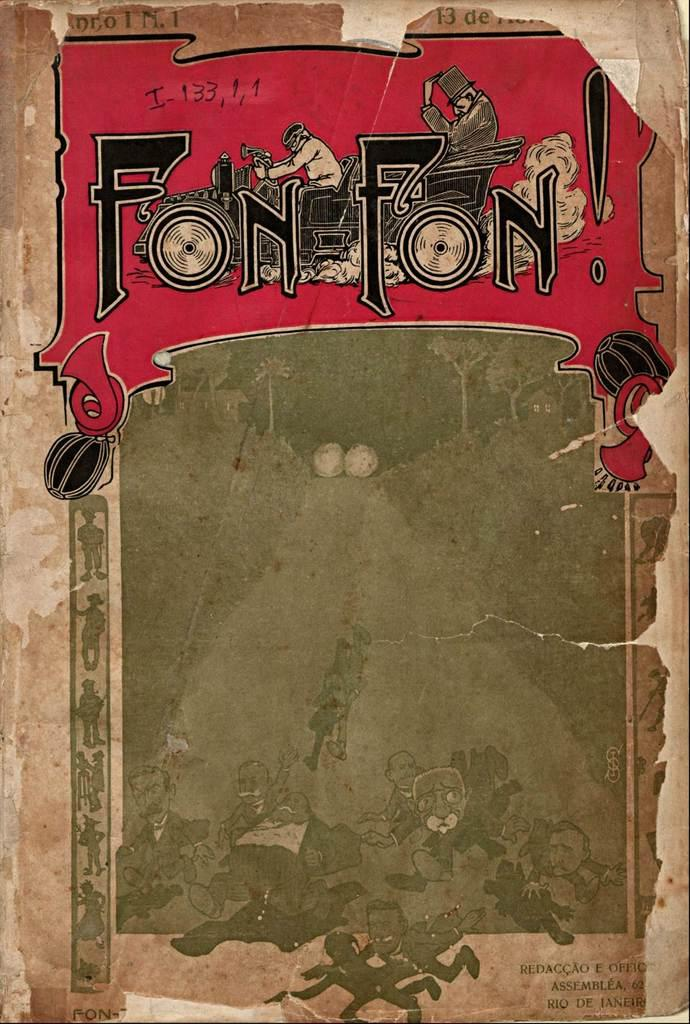<image>
Give a short and clear explanation of the subsequent image. a paper that is red, white, black, and green that says 'fon fon!' 